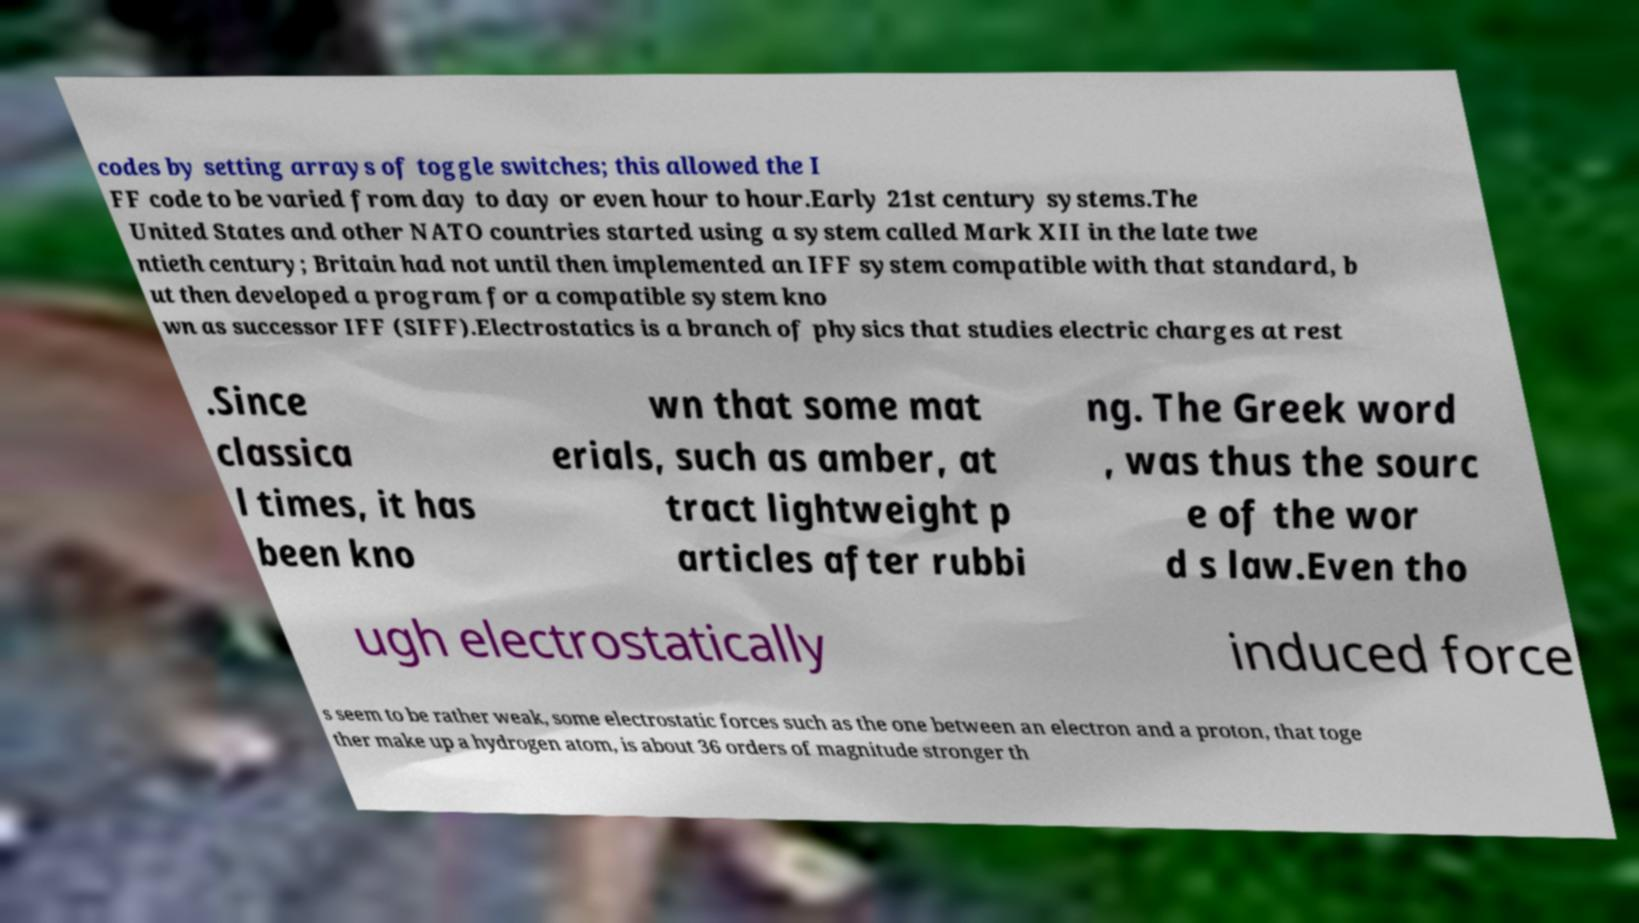For documentation purposes, I need the text within this image transcribed. Could you provide that? codes by setting arrays of toggle switches; this allowed the I FF code to be varied from day to day or even hour to hour.Early 21st century systems.The United States and other NATO countries started using a system called Mark XII in the late twe ntieth century; Britain had not until then implemented an IFF system compatible with that standard, b ut then developed a program for a compatible system kno wn as successor IFF (SIFF).Electrostatics is a branch of physics that studies electric charges at rest .Since classica l times, it has been kno wn that some mat erials, such as amber, at tract lightweight p articles after rubbi ng. The Greek word , was thus the sourc e of the wor d s law.Even tho ugh electrostatically induced force s seem to be rather weak, some electrostatic forces such as the one between an electron and a proton, that toge ther make up a hydrogen atom, is about 36 orders of magnitude stronger th 